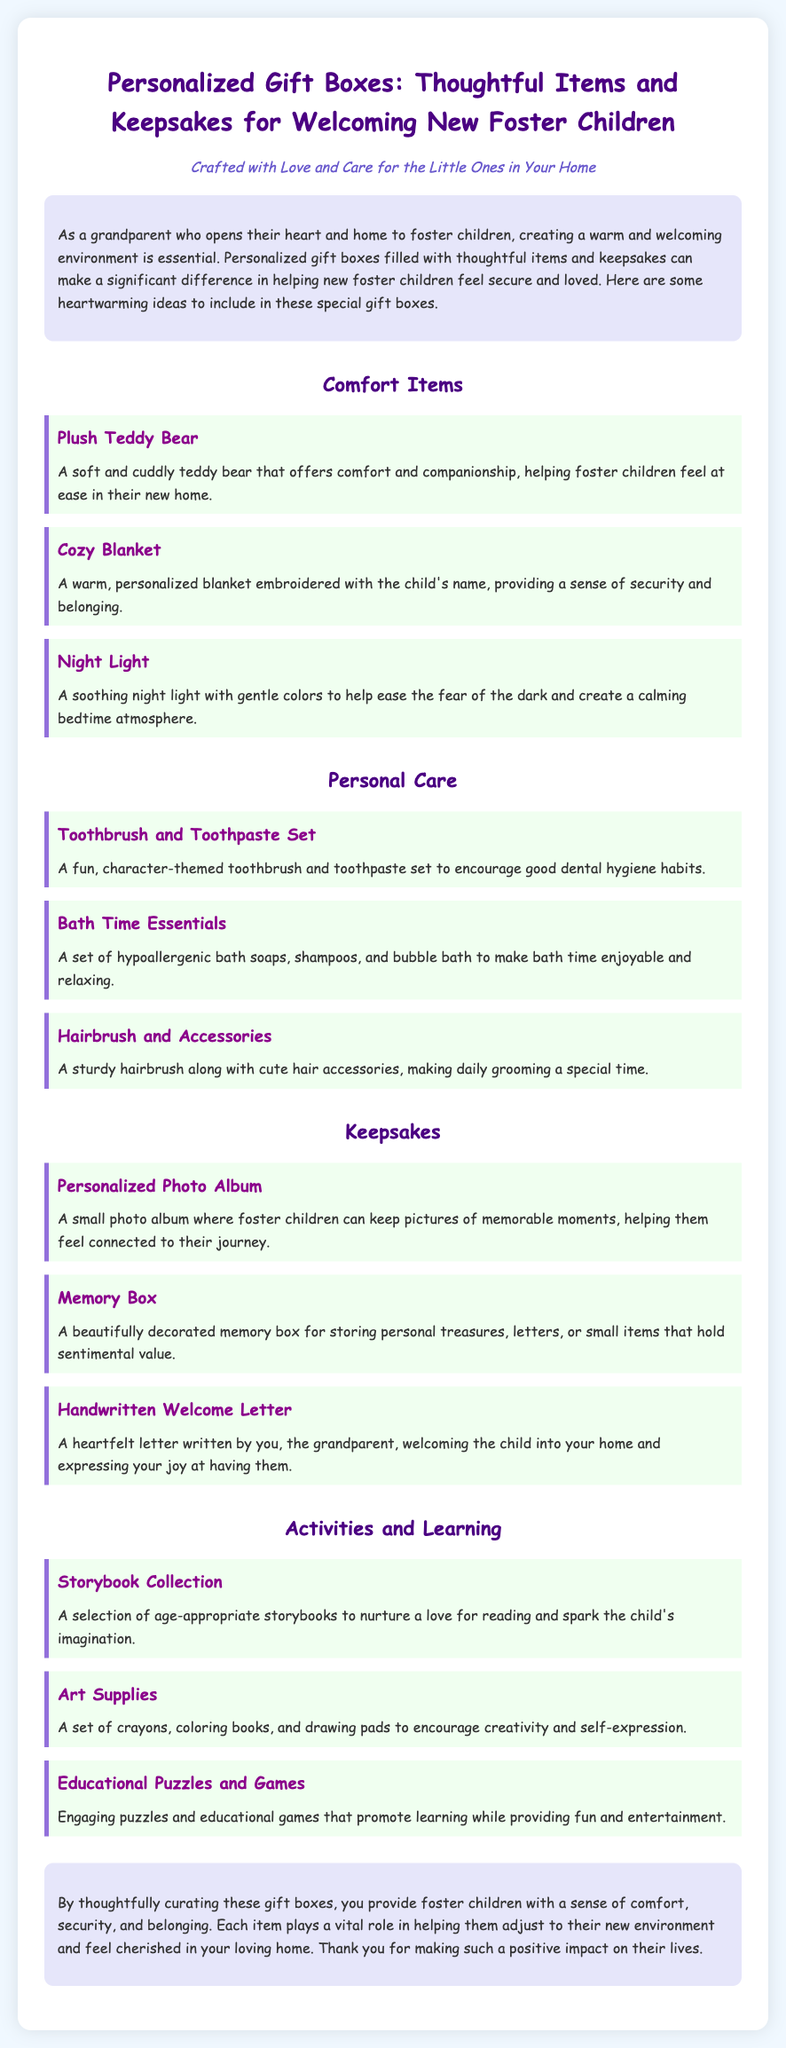What is the title of the document? The title is prominently displayed at the top of the document, indicating the main focus of the content.
Answer: Personalized Gift Boxes: Thoughtful Items and Keepsakes for Welcoming New Foster Children How many sections are there in the document? The document contains multiple sections, each focusing on different categories of items to include in the gift boxes.
Answer: Four What item is described as comforting companionship? The document lists various items, with one specifically noted for providing comfort and companionship.
Answer: Plush Teddy Bear What personalized item is mentioned for the child to feel a sense of security? The document includes a personalized item that offers a sense of belonging to the foster child.
Answer: Cozy Blanket What type of letter is included in the keepsakes? The document specifies a particular type of letter that adds a personal touch to the gift box.
Answer: Handwritten Welcome Letter What collection is provided to nurture a love for reading? The document mentions an educational item aimed at fostering a love for reading among children.
Answer: Storybook Collection What activity item encourages creativity and self-expression? Among the items listed in the document, one specifically focuses on nurturing creativity.
Answer: Art Supplies Which cleaning set is included to promote good dental hygiene? The document describes a dental hygiene product aimed at encouraging healthy habits for children.
Answer: Toothbrush and Toothpaste Set What is the main purpose of these personalized gift boxes? The document clearly states the overarching goal of providing these gift boxes to foster children.
Answer: Comfort, security, and belonging 